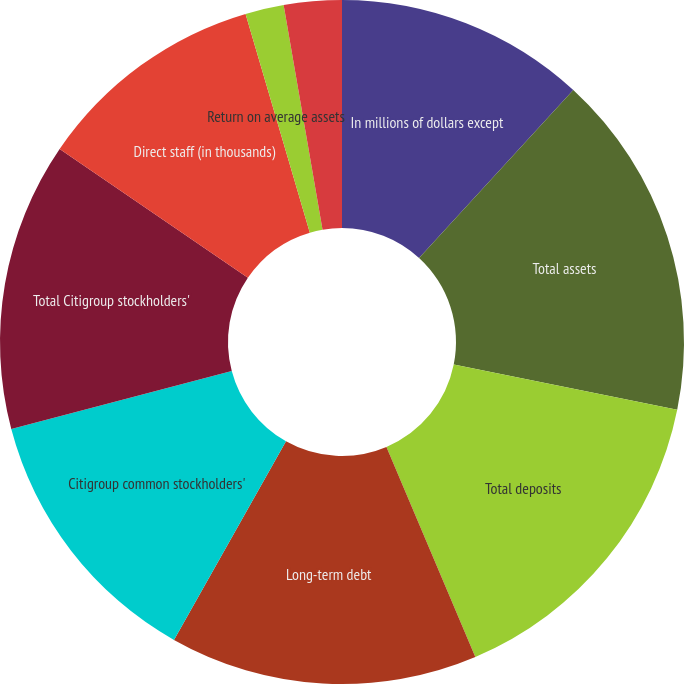Convert chart. <chart><loc_0><loc_0><loc_500><loc_500><pie_chart><fcel>In millions of dollars except<fcel>Total assets<fcel>Total deposits<fcel>Long-term debt<fcel>Citigroup common stockholders'<fcel>Total Citigroup stockholders'<fcel>Direct staff (in thousands)<fcel>Return on average assets<fcel>Return on average common<fcel>Return on average total<nl><fcel>11.82%<fcel>16.36%<fcel>15.45%<fcel>14.55%<fcel>12.73%<fcel>13.64%<fcel>10.91%<fcel>0.0%<fcel>1.82%<fcel>2.73%<nl></chart> 